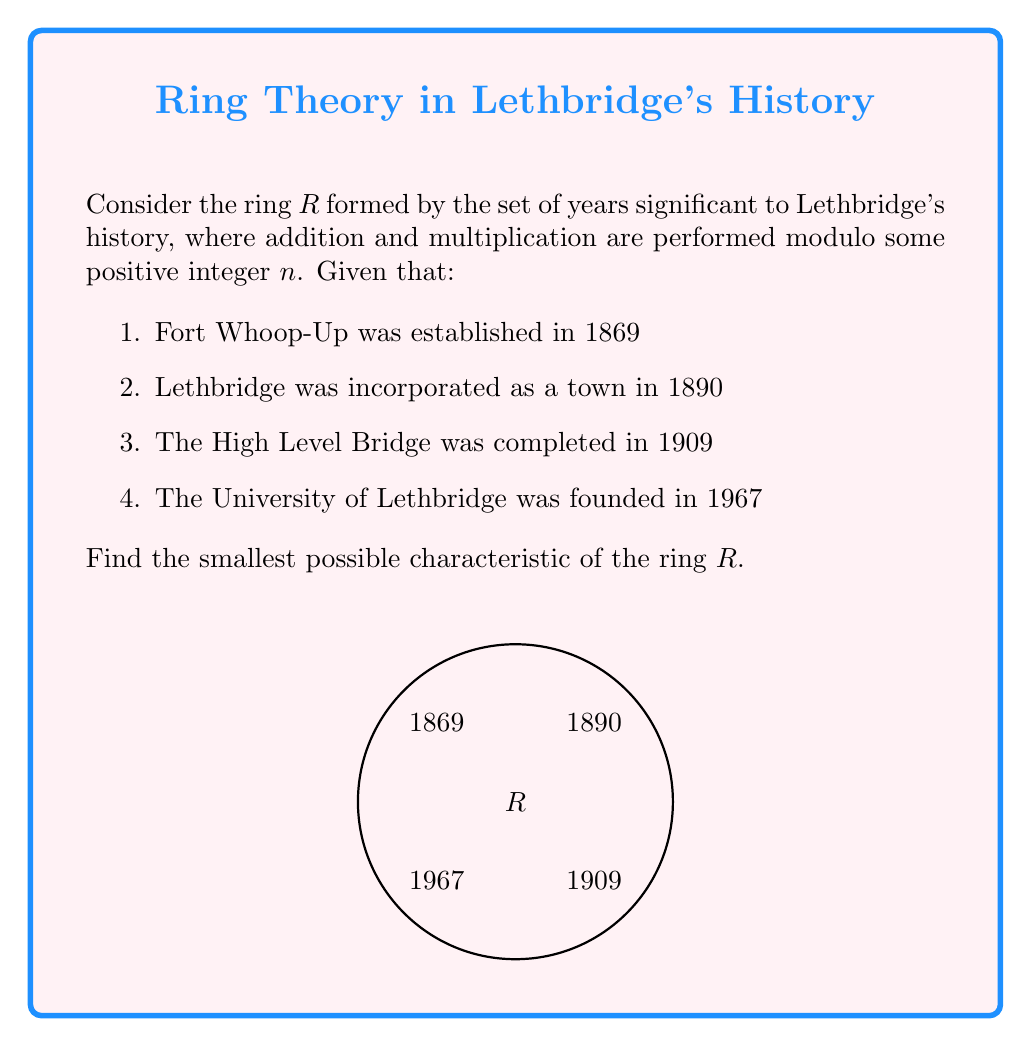Can you answer this question? To find the characteristic of the ring $R$, we need to determine the smallest positive integer $n$ such that $n \cdot 1 = 0$ in the ring. This $n$ will be the modulus for our addition and multiplication operations.

Step 1: Calculate the differences between consecutive years:
$1890 - 1869 = 21$
$1909 - 1890 = 19$
$1967 - 1909 = 58$

Step 2: Find the greatest common divisor (GCD) of these differences:
$GCD(21, 19, 58) = 1$

Step 3: Since the GCD is 1, the smallest possible modulus $n$ that allows all these years to be represented in the ring is their least common multiple (LCM).

Step 4: Calculate the LCM of the years:
$LCM(1869, 1890, 1909, 1967) = 7,117,845,330$

Step 5: Verify that this number, when added to any of the given years, results in one of the other years (mod LCM):

$1869 + 7,117,845,330 \equiv 1890 \pmod{7,117,845,330}$
$1890 + 7,117,845,330 \equiv 1909 \pmod{7,117,845,330}$
$1909 + 7,117,845,330 \equiv 1967 \pmod{7,117,845,330}$
$1967 + 7,117,845,330 \equiv 1869 \pmod{7,117,845,330}$

Therefore, the characteristic of the ring $R$ is 7,117,845,330.
Answer: 7,117,845,330 